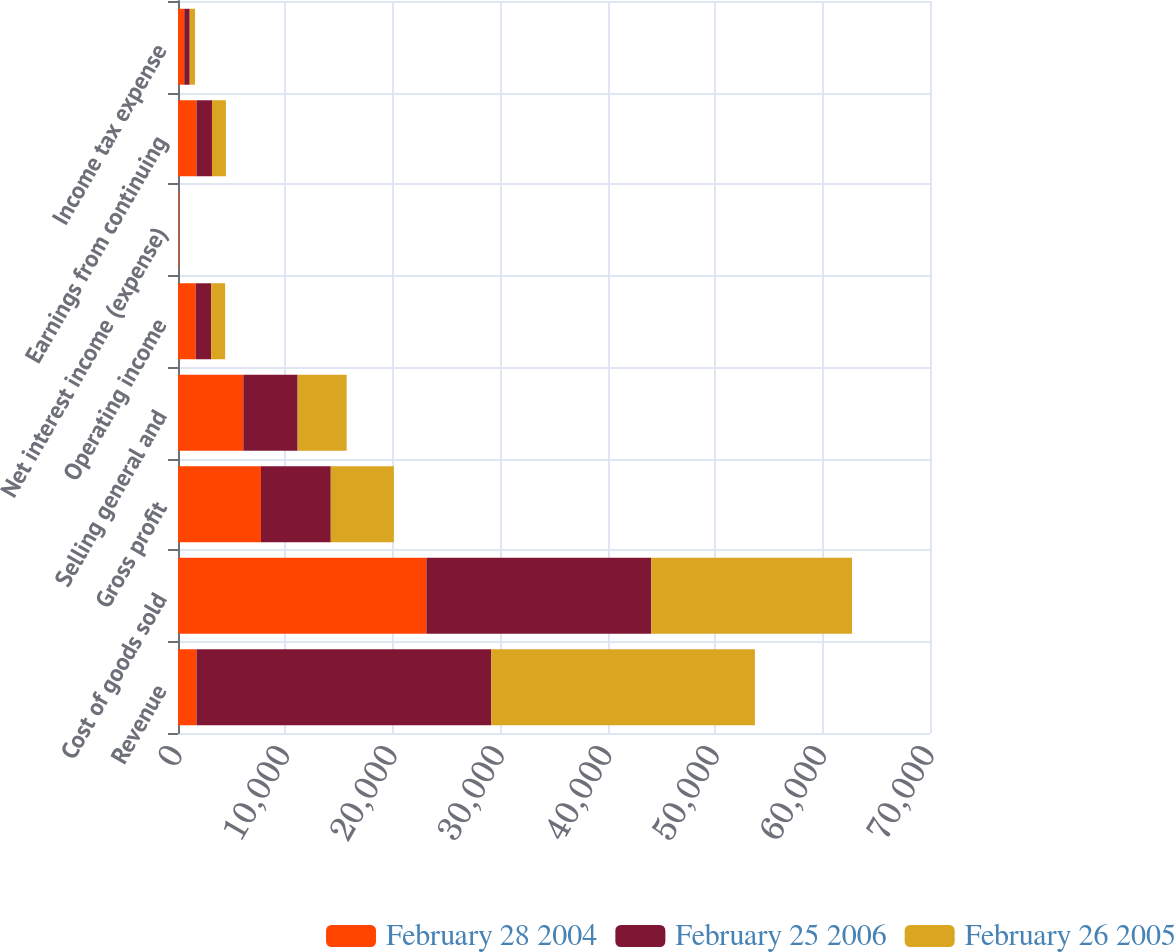Convert chart to OTSL. <chart><loc_0><loc_0><loc_500><loc_500><stacked_bar_chart><ecel><fcel>Revenue<fcel>Cost of goods sold<fcel>Gross profit<fcel>Selling general and<fcel>Operating income<fcel>Net interest income (expense)<fcel>Earnings from continuing<fcel>Income tax expense<nl><fcel>February 28 2004<fcel>1721<fcel>23122<fcel>7726<fcel>6082<fcel>1644<fcel>77<fcel>1721<fcel>581<nl><fcel>February 25 2006<fcel>27433<fcel>20938<fcel>6495<fcel>5053<fcel>1442<fcel>1<fcel>1443<fcel>509<nl><fcel>February 26 2005<fcel>24548<fcel>18677<fcel>5871<fcel>4567<fcel>1304<fcel>8<fcel>1296<fcel>496<nl></chart> 